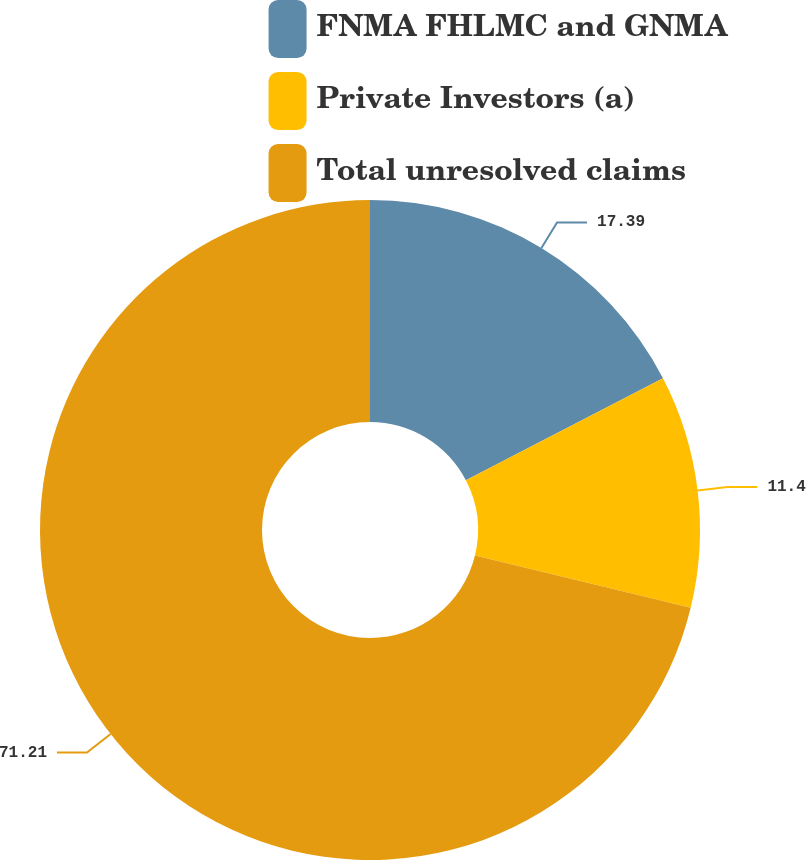Convert chart to OTSL. <chart><loc_0><loc_0><loc_500><loc_500><pie_chart><fcel>FNMA FHLMC and GNMA<fcel>Private Investors (a)<fcel>Total unresolved claims<nl><fcel>17.39%<fcel>11.4%<fcel>71.21%<nl></chart> 